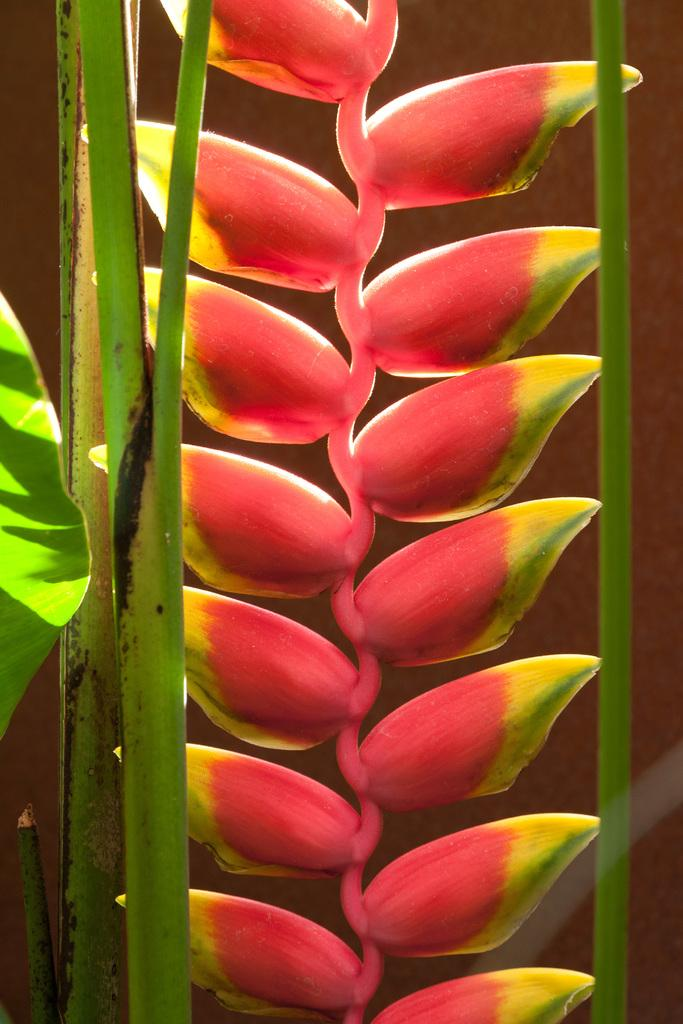What type of plant is featured in the image? The image contains a lobster claw plant. What is the weight of the celery in the image? There is no celery present in the image, so it is not possible to determine its weight. 